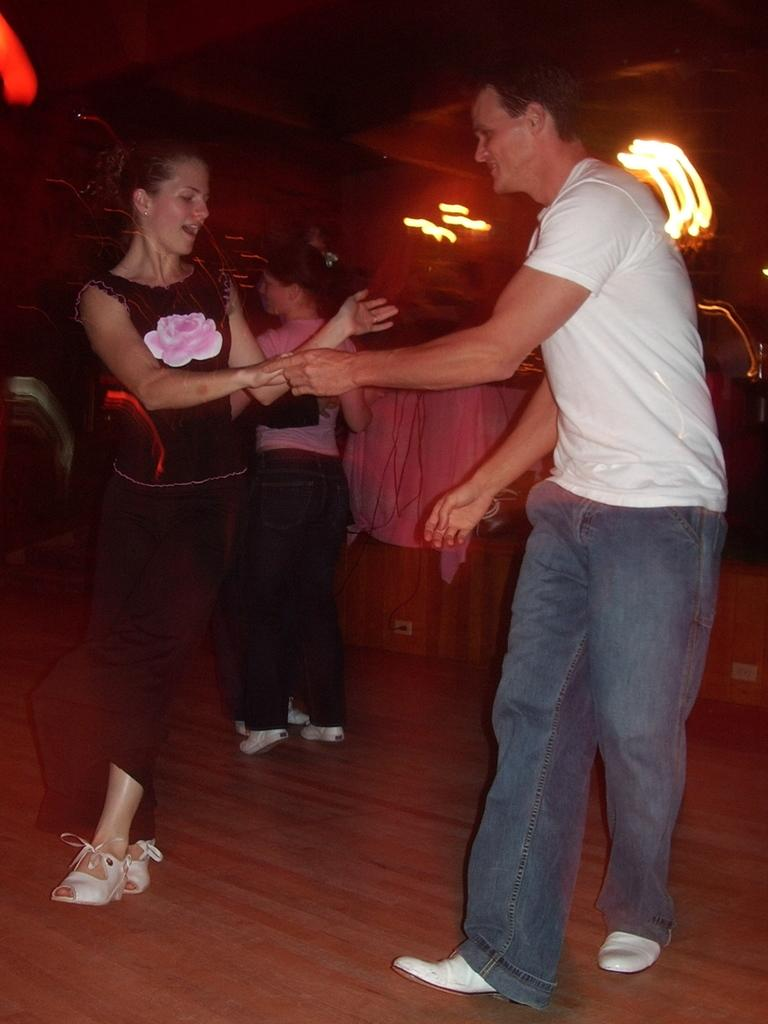What are the people in the image doing? The people in the image are dancing. What type of floor can be seen in the image? The floor they are dancing on is wooden. Can you describe the background of the image? The background of the image is blurred. What type of club can be seen in the image? There is no club present in the image; it features people dancing on a wooden floor with a blurred background. 